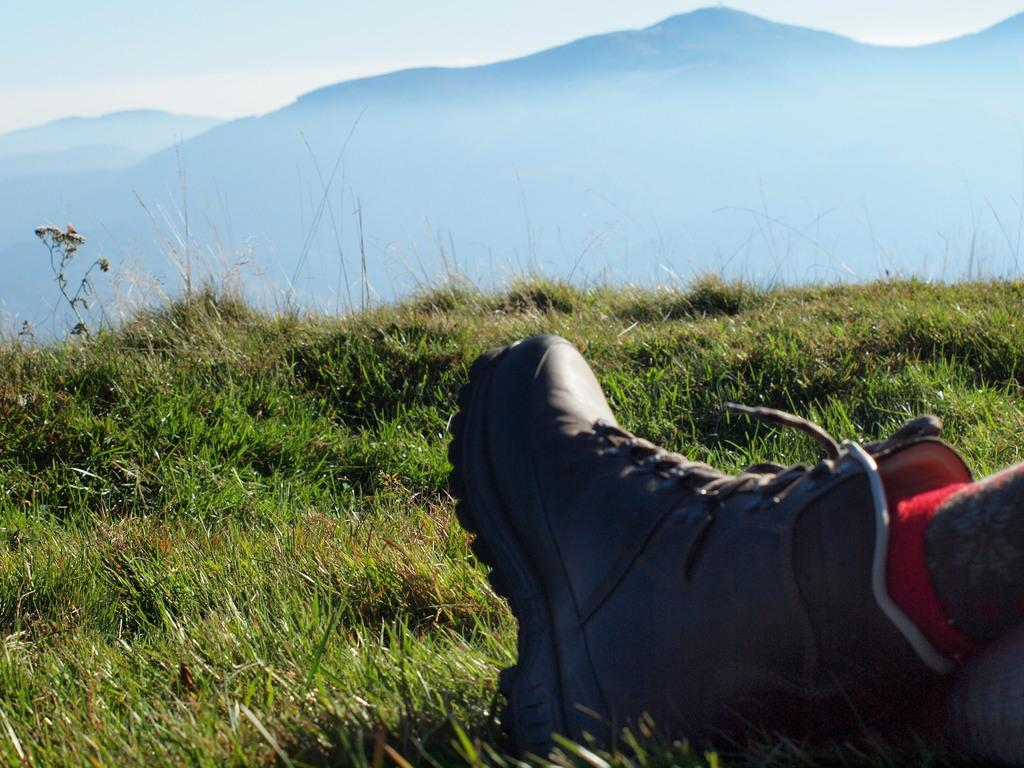What can be seen on the right side of the image? There is a leg of a person along with a shoe on the right side of the image. What is visible in the background of the image? The sky, hills, and grass are present in the background of the image. What type of creature can be seen using its throat to communicate in the image? There is no creature present in the image, and therefore no such communication can be observed. 